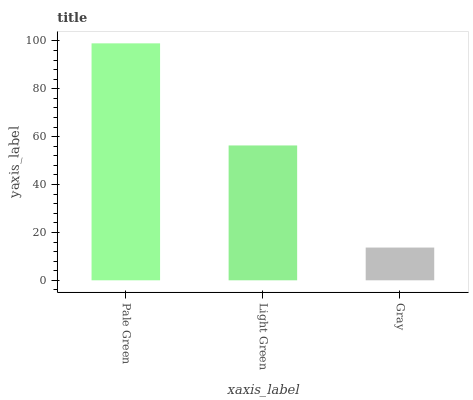Is Gray the minimum?
Answer yes or no. Yes. Is Pale Green the maximum?
Answer yes or no. Yes. Is Light Green the minimum?
Answer yes or no. No. Is Light Green the maximum?
Answer yes or no. No. Is Pale Green greater than Light Green?
Answer yes or no. Yes. Is Light Green less than Pale Green?
Answer yes or no. Yes. Is Light Green greater than Pale Green?
Answer yes or no. No. Is Pale Green less than Light Green?
Answer yes or no. No. Is Light Green the high median?
Answer yes or no. Yes. Is Light Green the low median?
Answer yes or no. Yes. Is Pale Green the high median?
Answer yes or no. No. Is Pale Green the low median?
Answer yes or no. No. 